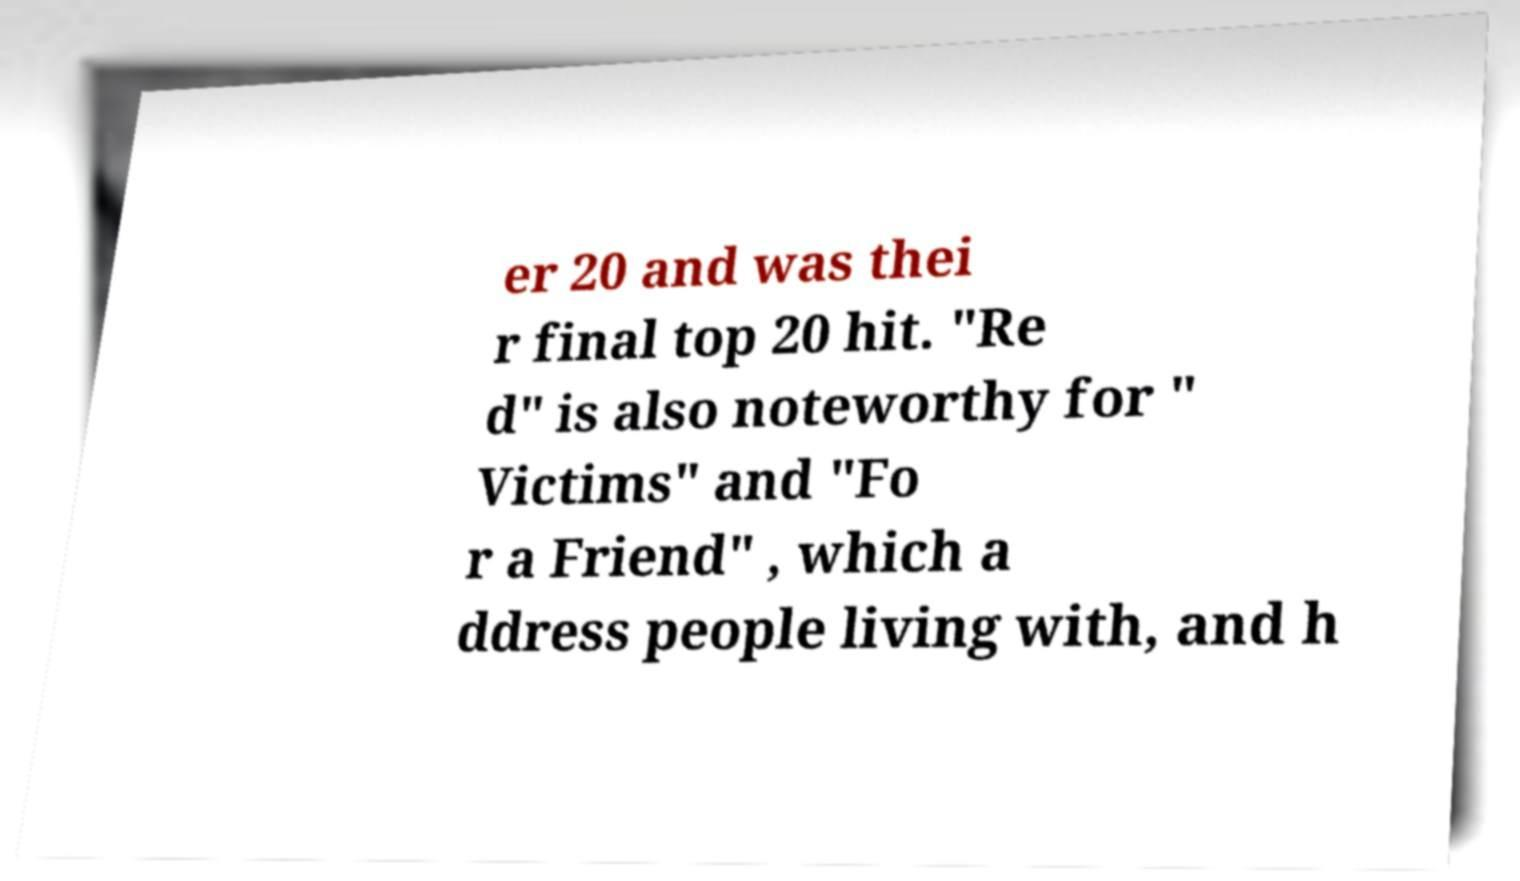There's text embedded in this image that I need extracted. Can you transcribe it verbatim? er 20 and was thei r final top 20 hit. "Re d" is also noteworthy for " Victims" and "Fo r a Friend" , which a ddress people living with, and h 